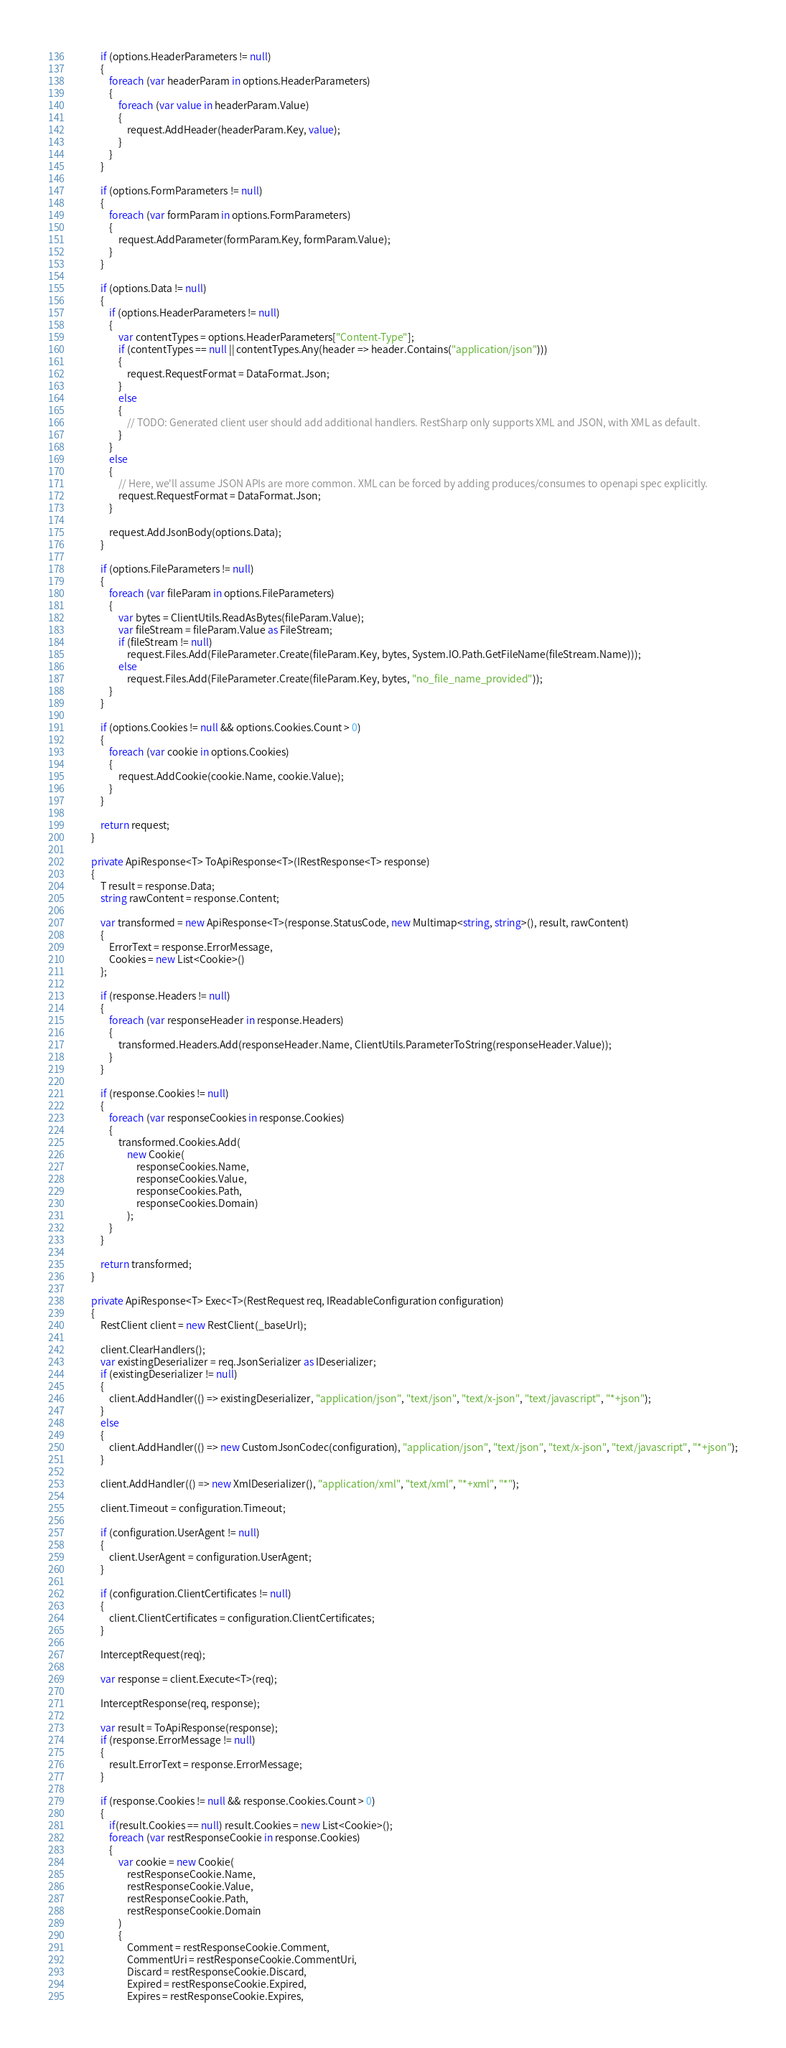Convert code to text. <code><loc_0><loc_0><loc_500><loc_500><_C#_>            if (options.HeaderParameters != null)
            {
                foreach (var headerParam in options.HeaderParameters)
                {
                    foreach (var value in headerParam.Value)
                    {
                        request.AddHeader(headerParam.Key, value);
                    }
                }
            }

            if (options.FormParameters != null)
            {
                foreach (var formParam in options.FormParameters)
                {
                    request.AddParameter(formParam.Key, formParam.Value);
                }
            }

            if (options.Data != null)
            {
                if (options.HeaderParameters != null)
                {
                    var contentTypes = options.HeaderParameters["Content-Type"];
                    if (contentTypes == null || contentTypes.Any(header => header.Contains("application/json")))
                    {
                        request.RequestFormat = DataFormat.Json;
                    }
                    else
                    {
                        // TODO: Generated client user should add additional handlers. RestSharp only supports XML and JSON, with XML as default.
                    }
                }
                else
                {
                    // Here, we'll assume JSON APIs are more common. XML can be forced by adding produces/consumes to openapi spec explicitly.
                    request.RequestFormat = DataFormat.Json;
                }

                request.AddJsonBody(options.Data);
            }

            if (options.FileParameters != null)
            {
                foreach (var fileParam in options.FileParameters)
                {
                    var bytes = ClientUtils.ReadAsBytes(fileParam.Value);
                    var fileStream = fileParam.Value as FileStream;
                    if (fileStream != null)
                        request.Files.Add(FileParameter.Create(fileParam.Key, bytes, System.IO.Path.GetFileName(fileStream.Name)));
                    else
                        request.Files.Add(FileParameter.Create(fileParam.Key, bytes, "no_file_name_provided"));
                }
            }

            if (options.Cookies != null && options.Cookies.Count > 0)
            {
                foreach (var cookie in options.Cookies)
                {
                    request.AddCookie(cookie.Name, cookie.Value);
                }
            }
            
            return request;
        }

        private ApiResponse<T> ToApiResponse<T>(IRestResponse<T> response)
        {
            T result = response.Data;
            string rawContent = response.Content;

            var transformed = new ApiResponse<T>(response.StatusCode, new Multimap<string, string>(), result, rawContent)
            {
                ErrorText = response.ErrorMessage,
                Cookies = new List<Cookie>()
            };
            
            if (response.Headers != null)
            {
                foreach (var responseHeader in response.Headers)
                {
                    transformed.Headers.Add(responseHeader.Name, ClientUtils.ParameterToString(responseHeader.Value));
                }
            }

            if (response.Cookies != null)
            {
                foreach (var responseCookies in response.Cookies)
                {
                    transformed.Cookies.Add(
                        new Cookie(
                            responseCookies.Name, 
                            responseCookies.Value, 
                            responseCookies.Path, 
                            responseCookies.Domain)
                        );
                }
            }

            return transformed;
        }

        private ApiResponse<T> Exec<T>(RestRequest req, IReadableConfiguration configuration)
        {
            RestClient client = new RestClient(_baseUrl);

            client.ClearHandlers();
            var existingDeserializer = req.JsonSerializer as IDeserializer;
            if (existingDeserializer != null)
            {
                client.AddHandler(() => existingDeserializer, "application/json", "text/json", "text/x-json", "text/javascript", "*+json");
            }
            else
            {
                client.AddHandler(() => new CustomJsonCodec(configuration), "application/json", "text/json", "text/x-json", "text/javascript", "*+json");
            }

            client.AddHandler(() => new XmlDeserializer(), "application/xml", "text/xml", "*+xml", "*");

            client.Timeout = configuration.Timeout;

            if (configuration.UserAgent != null)
            {
                client.UserAgent = configuration.UserAgent;
            }

            if (configuration.ClientCertificates != null)
            {
                client.ClientCertificates = configuration.ClientCertificates;
            }

            InterceptRequest(req);

            var response = client.Execute<T>(req);

            InterceptResponse(req, response);

            var result = ToApiResponse(response);
            if (response.ErrorMessage != null)
            {
                result.ErrorText = response.ErrorMessage;
            }

            if (response.Cookies != null && response.Cookies.Count > 0)
            {
                if(result.Cookies == null) result.Cookies = new List<Cookie>();
                foreach (var restResponseCookie in response.Cookies)
                {
                    var cookie = new Cookie(
                        restResponseCookie.Name,
                        restResponseCookie.Value,
                        restResponseCookie.Path,
                        restResponseCookie.Domain
                    )
                    {
                        Comment = restResponseCookie.Comment,
                        CommentUri = restResponseCookie.CommentUri,
                        Discard = restResponseCookie.Discard,
                        Expired = restResponseCookie.Expired,
                        Expires = restResponseCookie.Expires,</code> 